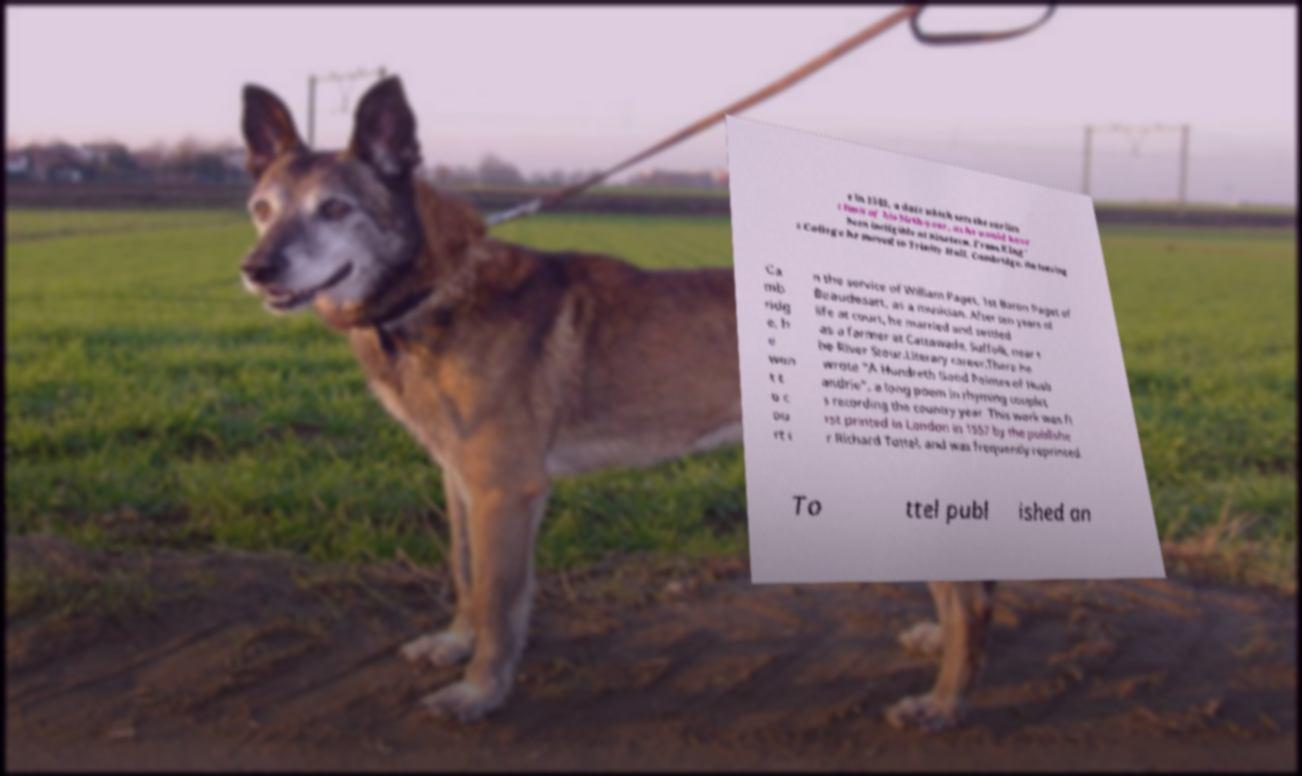There's text embedded in this image that I need extracted. Can you transcribe it verbatim? e in 1543, a date which sets the earlies t limit of his birth-year, as he would have been ineligible at nineteen. From King' s College he moved to Trinity Hall, Cambridge. On leaving Ca mb ridg e, h e wen t t o c ou rt i n the service of William Paget, 1st Baron Paget of Beaudesart, as a musician. After ten years of life at court, he married and settled as a farmer at Cattawade, Suffolk, near t he River Stour.Literary career.There he wrote "A Hundreth Good Pointes of Husb andrie", a long poem in rhyming couplet s recording the country year. This work was fi rst printed in London in 1557 by the publishe r Richard Tottel, and was frequently reprinted. To ttel publ ished an 